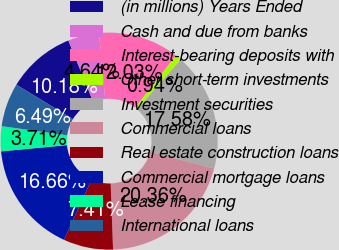Convert chart to OTSL. <chart><loc_0><loc_0><loc_500><loc_500><pie_chart><fcel>(in millions) Years Ended<fcel>Cash and due from banks<fcel>Interest-bearing deposits with<fcel>Other short-term investments<fcel>Investment securities<fcel>Commercial loans<fcel>Real estate construction loans<fcel>Commercial mortgage loans<fcel>Lease financing<fcel>International loans<nl><fcel>10.18%<fcel>4.64%<fcel>12.03%<fcel>0.94%<fcel>17.58%<fcel>20.36%<fcel>7.41%<fcel>16.66%<fcel>3.71%<fcel>6.49%<nl></chart> 